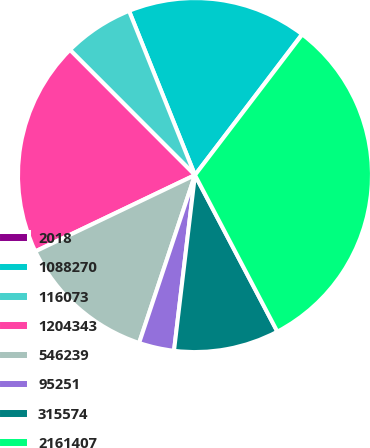Convert chart to OTSL. <chart><loc_0><loc_0><loc_500><loc_500><pie_chart><fcel>2018<fcel>1088270<fcel>116073<fcel>1204343<fcel>546239<fcel>95251<fcel>315574<fcel>2161407<nl><fcel>0.03%<fcel>16.42%<fcel>6.41%<fcel>19.61%<fcel>12.79%<fcel>3.22%<fcel>9.6%<fcel>31.92%<nl></chart> 